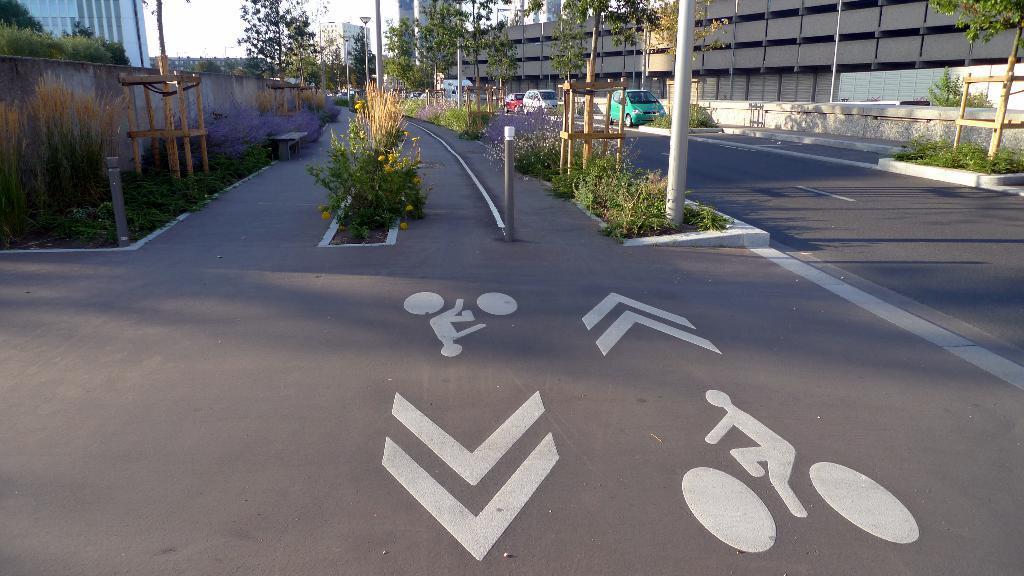Could you give a brief overview of what you see in this image? In the middle of the image we can see some plants, poles and vehicles on the road. Behind them we can see wall. Behind the wall we can see some buildings and trees. 